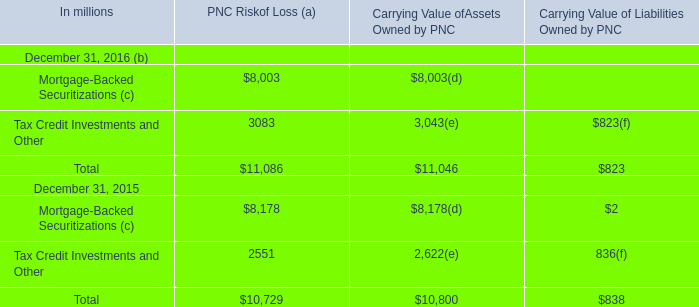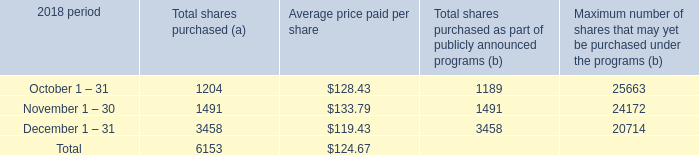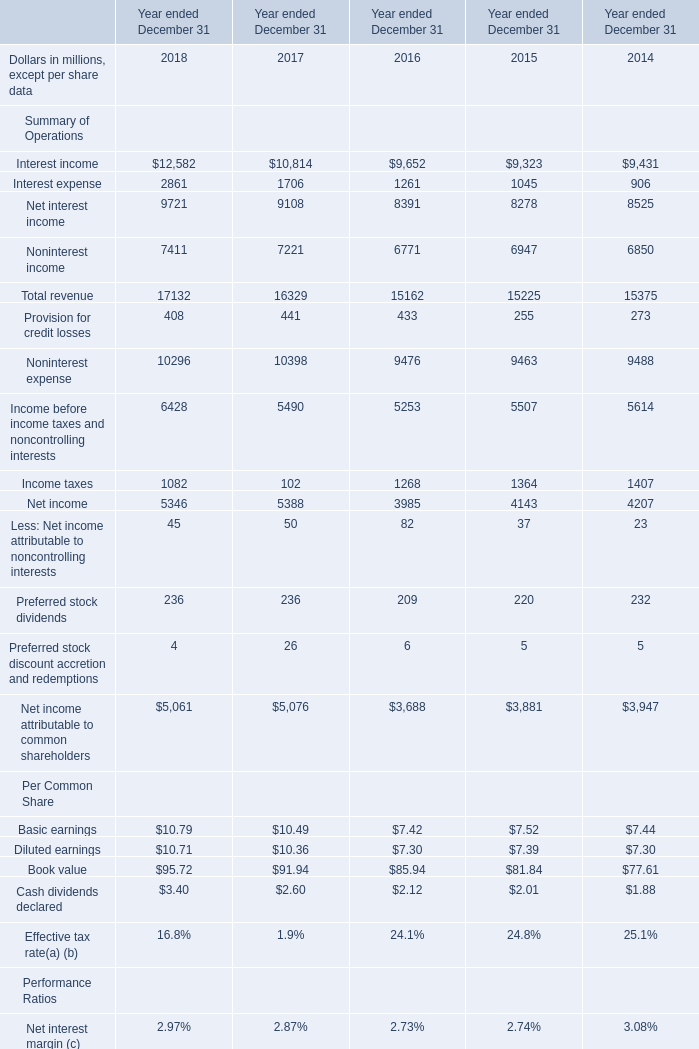What will Total revenue be like in 2019 ended December 31 if it develops with the same increasing rate as in 2018 ended December 31? (in million) 
Computations: (17132 * (1 + ((17132 - 16329) / 16329)))
Answer: 17974.48858. 